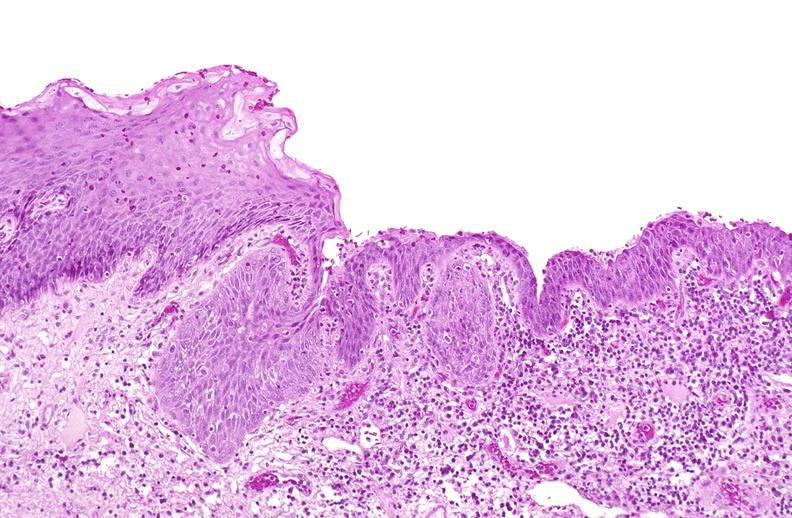does this fixed tissue show squamous metaplasia, renal pelvis due to nephrolithiasis?
Answer the question using a single word or phrase. No 